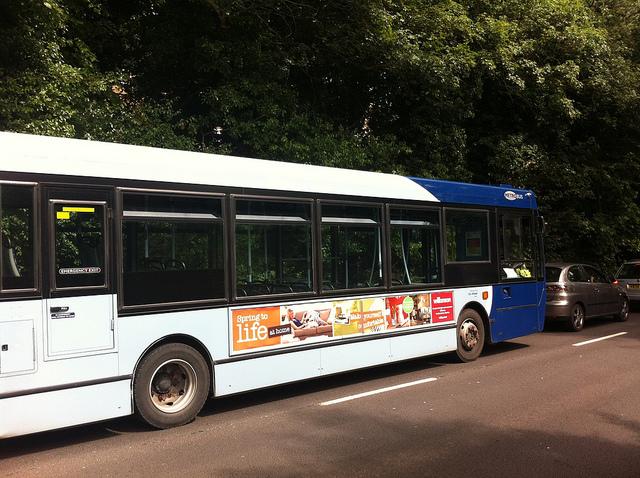Is the bus moving?
Concise answer only. Yes. How many buses?
Answer briefly. 1. What is in front of the bus?
Answer briefly. Car. What color is the majority of the side of the bus?
Answer briefly. White. What color is the bus?
Answer briefly. White and blue. Is this bus a double decker?
Concise answer only. No. 